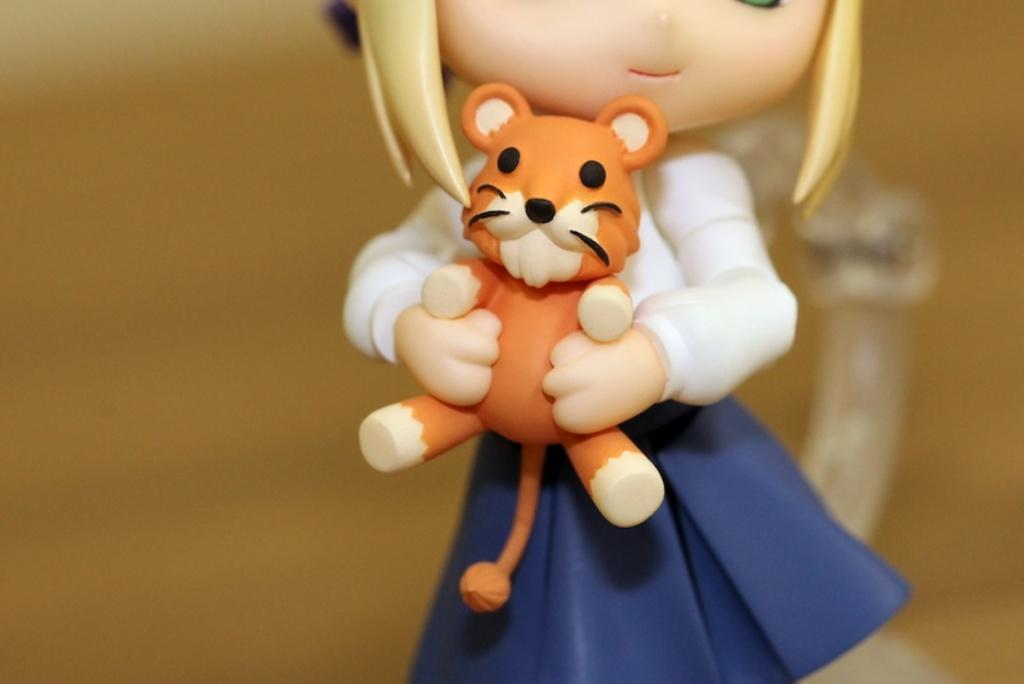What objects can be seen in the image? There are toys in the image. Can you describe the background of the image? The background of the image is blurred. How many birds are perched on the guitar in the image? There are no birds or guitars present in the image; it only contains toys. 